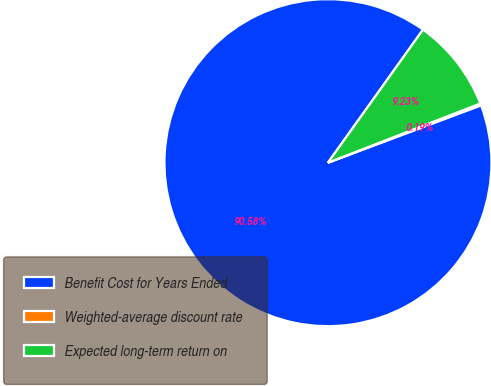Convert chart. <chart><loc_0><loc_0><loc_500><loc_500><pie_chart><fcel>Benefit Cost for Years Ended<fcel>Weighted-average discount rate<fcel>Expected long-term return on<nl><fcel>90.58%<fcel>0.19%<fcel>9.23%<nl></chart> 